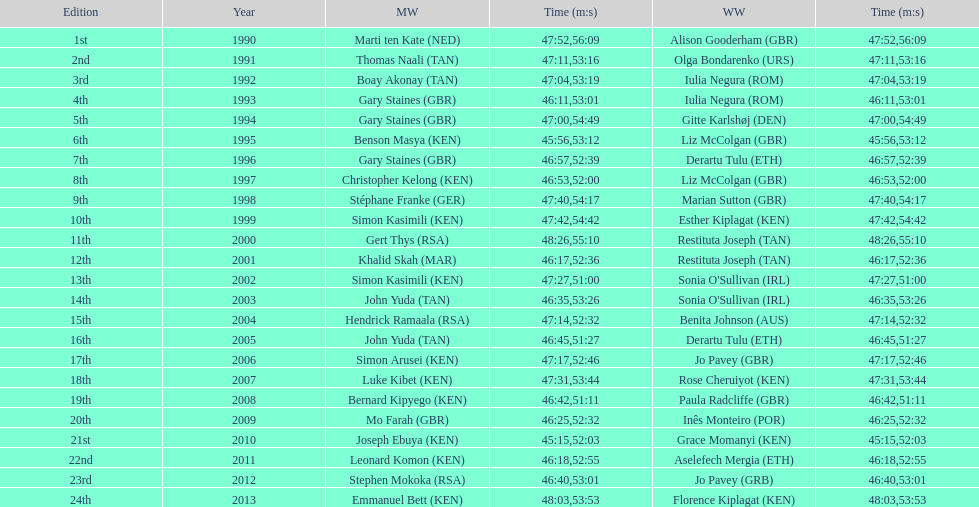What is the name of the first women's winner? Alison Gooderham. 